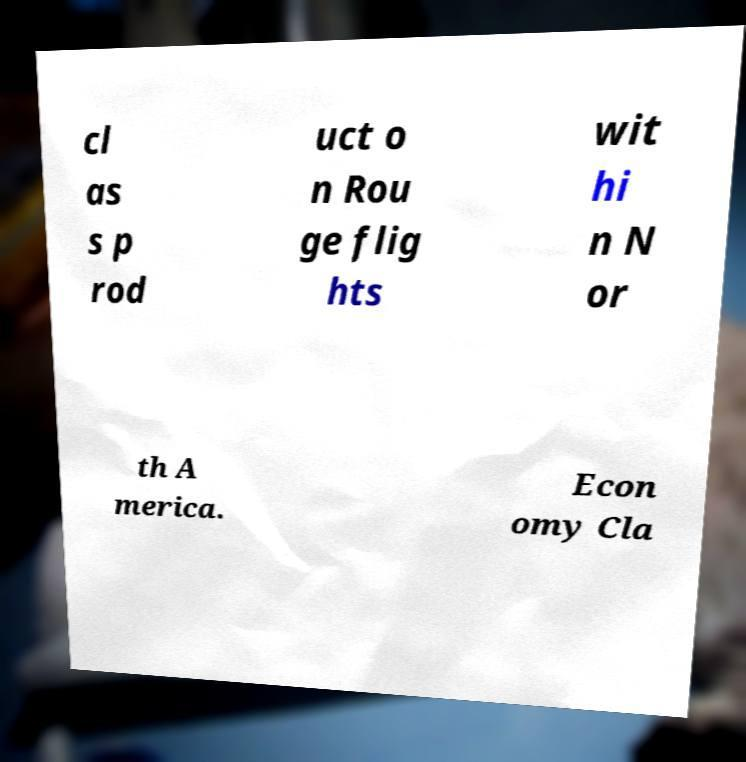I need the written content from this picture converted into text. Can you do that? cl as s p rod uct o n Rou ge flig hts wit hi n N or th A merica. Econ omy Cla 